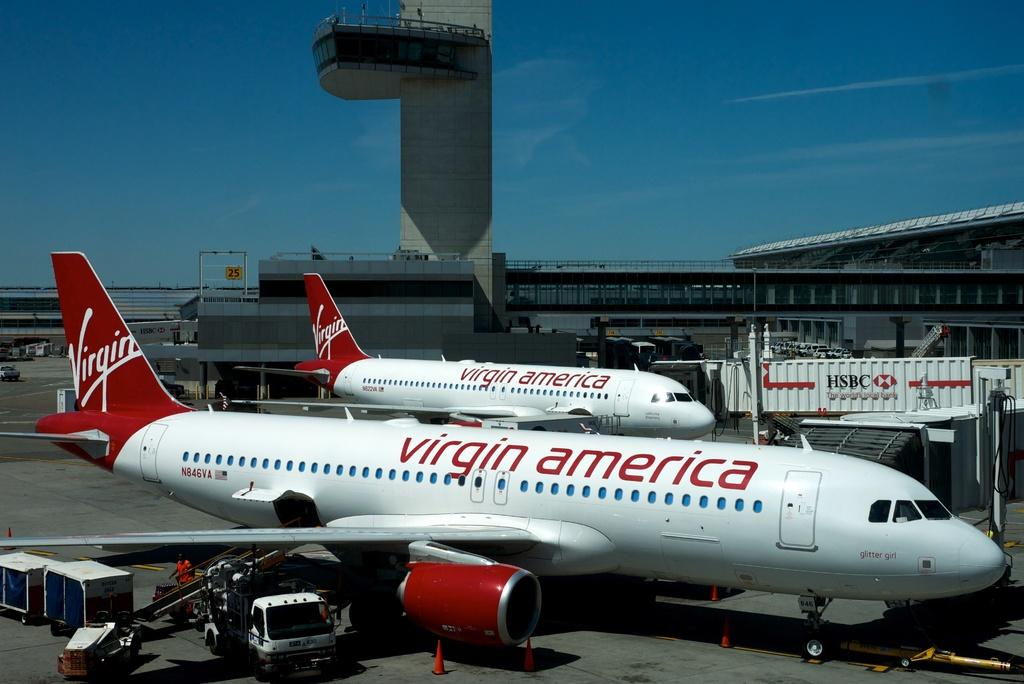<image>
Provide a brief description of the given image. Virgin America Airplane at the airport, and a beautiful blue sky background. 